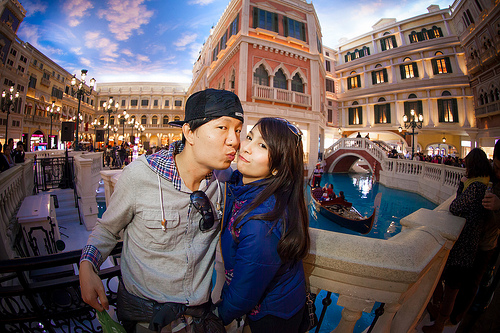<image>
Is there a man on the women? No. The man is not positioned on the women. They may be near each other, but the man is not supported by or resting on top of the women. Is there a hat in front of the head? No. The hat is not in front of the head. The spatial positioning shows a different relationship between these objects. 